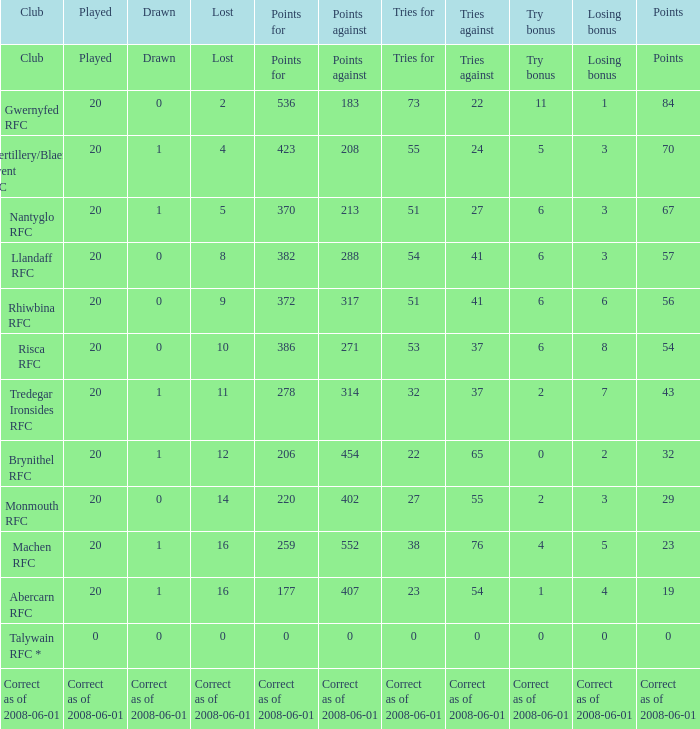Could you help me parse every detail presented in this table? {'header': ['Club', 'Played', 'Drawn', 'Lost', 'Points for', 'Points against', 'Tries for', 'Tries against', 'Try bonus', 'Losing bonus', 'Points'], 'rows': [['Club', 'Played', 'Drawn', 'Lost', 'Points for', 'Points against', 'Tries for', 'Tries against', 'Try bonus', 'Losing bonus', 'Points'], ['Gwernyfed RFC', '20', '0', '2', '536', '183', '73', '22', '11', '1', '84'], ['Abertillery/Blaenau Gwent RFC', '20', '1', '4', '423', '208', '55', '24', '5', '3', '70'], ['Nantyglo RFC', '20', '1', '5', '370', '213', '51', '27', '6', '3', '67'], ['Llandaff RFC', '20', '0', '8', '382', '288', '54', '41', '6', '3', '57'], ['Rhiwbina RFC', '20', '0', '9', '372', '317', '51', '41', '6', '6', '56'], ['Risca RFC', '20', '0', '10', '386', '271', '53', '37', '6', '8', '54'], ['Tredegar Ironsides RFC', '20', '1', '11', '278', '314', '32', '37', '2', '7', '43'], ['Brynithel RFC', '20', '1', '12', '206', '454', '22', '65', '0', '2', '32'], ['Monmouth RFC', '20', '0', '14', '220', '402', '27', '55', '2', '3', '29'], ['Machen RFC', '20', '1', '16', '259', '552', '38', '76', '4', '5', '23'], ['Abercarn RFC', '20', '1', '16', '177', '407', '23', '54', '1', '4', '19'], ['Talywain RFC *', '0', '0', '0', '0', '0', '0', '0', '0', '0', '0'], ['Correct as of 2008-06-01', 'Correct as of 2008-06-01', 'Correct as of 2008-06-01', 'Correct as of 2008-06-01', 'Correct as of 2008-06-01', 'Correct as of 2008-06-01', 'Correct as of 2008-06-01', 'Correct as of 2008-06-01', 'Correct as of 2008-06-01', 'Correct as of 2008-06-01', 'Correct as of 2008-06-01']]} What's the effort bonus that had 423 points? 5.0. 